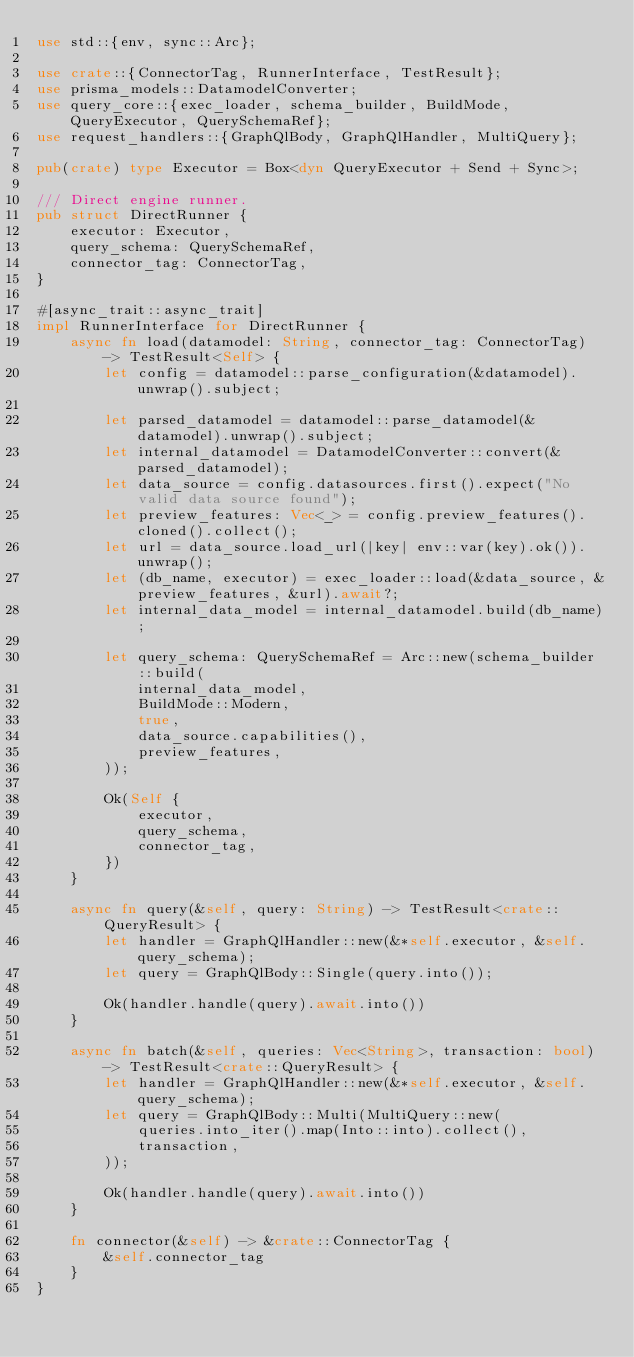<code> <loc_0><loc_0><loc_500><loc_500><_Rust_>use std::{env, sync::Arc};

use crate::{ConnectorTag, RunnerInterface, TestResult};
use prisma_models::DatamodelConverter;
use query_core::{exec_loader, schema_builder, BuildMode, QueryExecutor, QuerySchemaRef};
use request_handlers::{GraphQlBody, GraphQlHandler, MultiQuery};

pub(crate) type Executor = Box<dyn QueryExecutor + Send + Sync>;

/// Direct engine runner.
pub struct DirectRunner {
    executor: Executor,
    query_schema: QuerySchemaRef,
    connector_tag: ConnectorTag,
}

#[async_trait::async_trait]
impl RunnerInterface for DirectRunner {
    async fn load(datamodel: String, connector_tag: ConnectorTag) -> TestResult<Self> {
        let config = datamodel::parse_configuration(&datamodel).unwrap().subject;

        let parsed_datamodel = datamodel::parse_datamodel(&datamodel).unwrap().subject;
        let internal_datamodel = DatamodelConverter::convert(&parsed_datamodel);
        let data_source = config.datasources.first().expect("No valid data source found");
        let preview_features: Vec<_> = config.preview_features().cloned().collect();
        let url = data_source.load_url(|key| env::var(key).ok()).unwrap();
        let (db_name, executor) = exec_loader::load(&data_source, &preview_features, &url).await?;
        let internal_data_model = internal_datamodel.build(db_name);

        let query_schema: QuerySchemaRef = Arc::new(schema_builder::build(
            internal_data_model,
            BuildMode::Modern,
            true,
            data_source.capabilities(),
            preview_features,
        ));

        Ok(Self {
            executor,
            query_schema,
            connector_tag,
        })
    }

    async fn query(&self, query: String) -> TestResult<crate::QueryResult> {
        let handler = GraphQlHandler::new(&*self.executor, &self.query_schema);
        let query = GraphQlBody::Single(query.into());

        Ok(handler.handle(query).await.into())
    }

    async fn batch(&self, queries: Vec<String>, transaction: bool) -> TestResult<crate::QueryResult> {
        let handler = GraphQlHandler::new(&*self.executor, &self.query_schema);
        let query = GraphQlBody::Multi(MultiQuery::new(
            queries.into_iter().map(Into::into).collect(),
            transaction,
        ));

        Ok(handler.handle(query).await.into())
    }

    fn connector(&self) -> &crate::ConnectorTag {
        &self.connector_tag
    }
}
</code> 